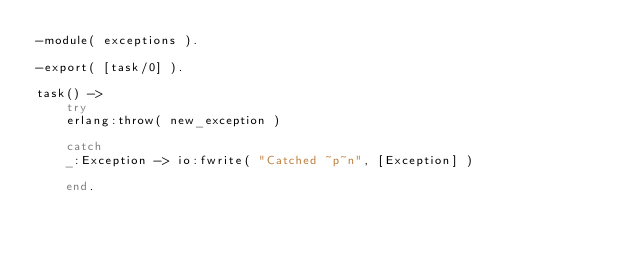Convert code to text. <code><loc_0><loc_0><loc_500><loc_500><_Erlang_>-module( exceptions ).

-export( [task/0] ).

task() ->
    try
    erlang:throw( new_exception )

    catch
    _:Exception -> io:fwrite( "Catched ~p~n", [Exception] )

    end.
</code> 